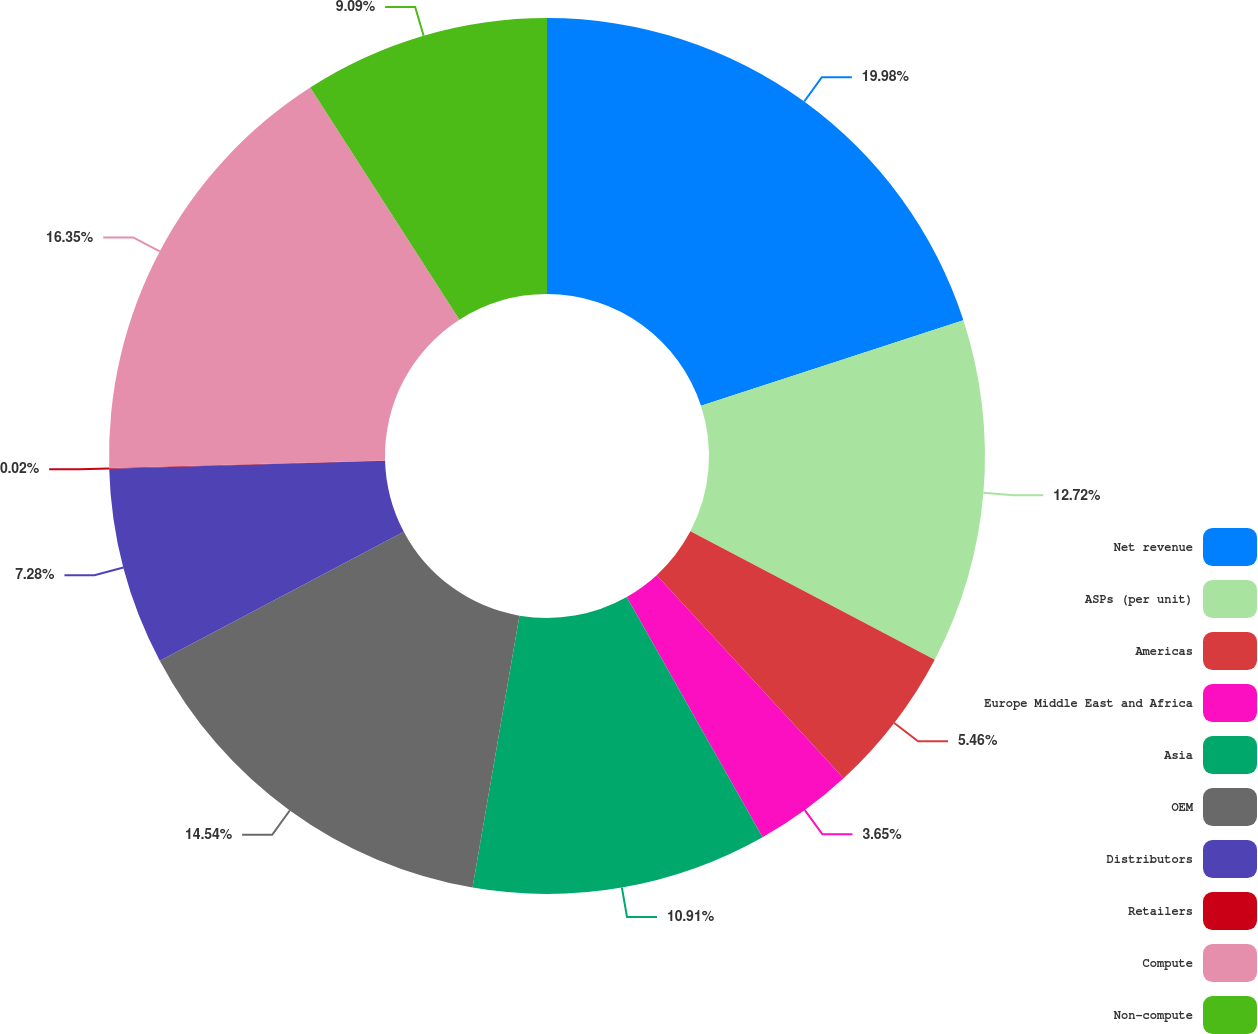Convert chart to OTSL. <chart><loc_0><loc_0><loc_500><loc_500><pie_chart><fcel>Net revenue<fcel>ASPs (per unit)<fcel>Americas<fcel>Europe Middle East and Africa<fcel>Asia<fcel>OEM<fcel>Distributors<fcel>Retailers<fcel>Compute<fcel>Non-compute<nl><fcel>19.98%<fcel>12.72%<fcel>5.46%<fcel>3.65%<fcel>10.91%<fcel>14.54%<fcel>7.28%<fcel>0.02%<fcel>16.35%<fcel>9.09%<nl></chart> 